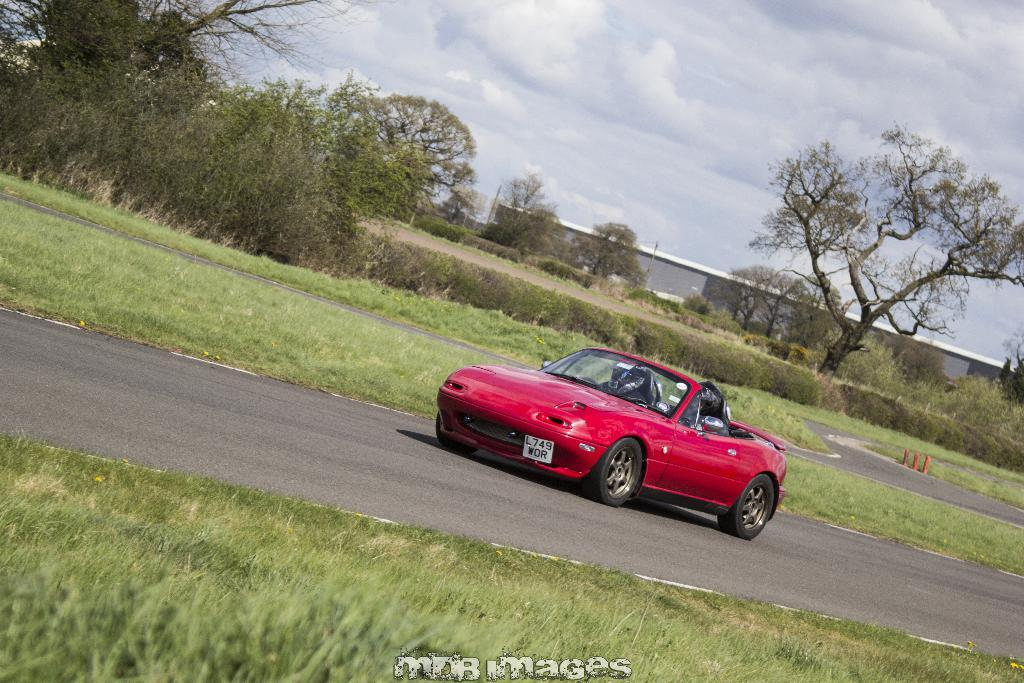What is the main subject of the image? There is a car in the center of the image. Where is the car located? The car is on the road. What can be seen at the bottom of the image? There is grass and text at the bottom of the image. What is visible in the background of the image? There is a road, trees, at least one building, plants, the sky, and clouds in the background. What type of button is being used to control the car in the image? There is no button present in the image, and the car is not being controlled by any visible means. 